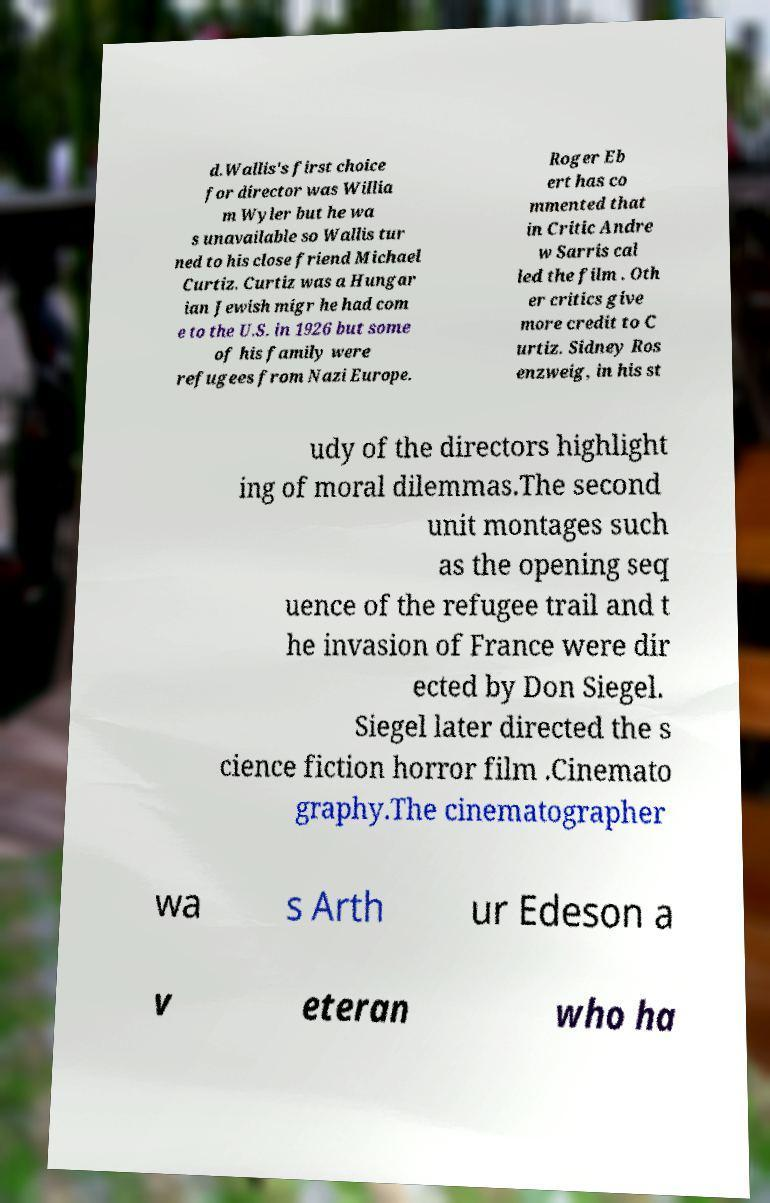There's text embedded in this image that I need extracted. Can you transcribe it verbatim? d.Wallis's first choice for director was Willia m Wyler but he wa s unavailable so Wallis tur ned to his close friend Michael Curtiz. Curtiz was a Hungar ian Jewish migr he had com e to the U.S. in 1926 but some of his family were refugees from Nazi Europe. Roger Eb ert has co mmented that in Critic Andre w Sarris cal led the film . Oth er critics give more credit to C urtiz. Sidney Ros enzweig, in his st udy of the directors highlight ing of moral dilemmas.The second unit montages such as the opening seq uence of the refugee trail and t he invasion of France were dir ected by Don Siegel. Siegel later directed the s cience fiction horror film .Cinemato graphy.The cinematographer wa s Arth ur Edeson a v eteran who ha 